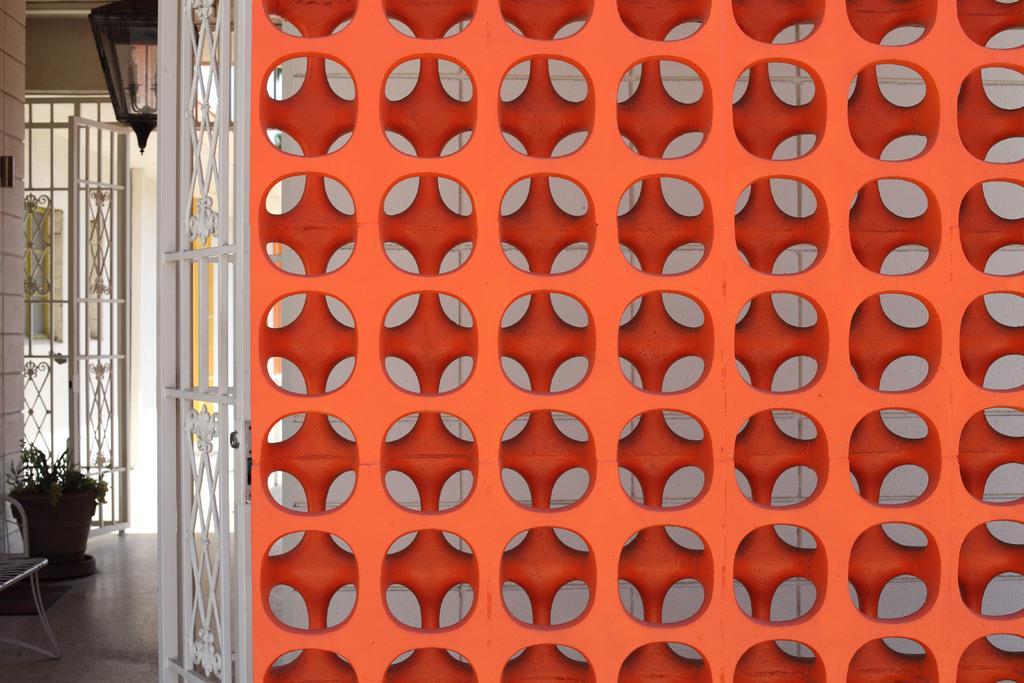Please provide a concise description of this image. In this picture I can see the red color plastic partition which is placed near to the wall. On the left I can see the gates, door, window, pot and plant. In the bottom left corner there is a chair. In the top left there is a light which is placed on the roof. 